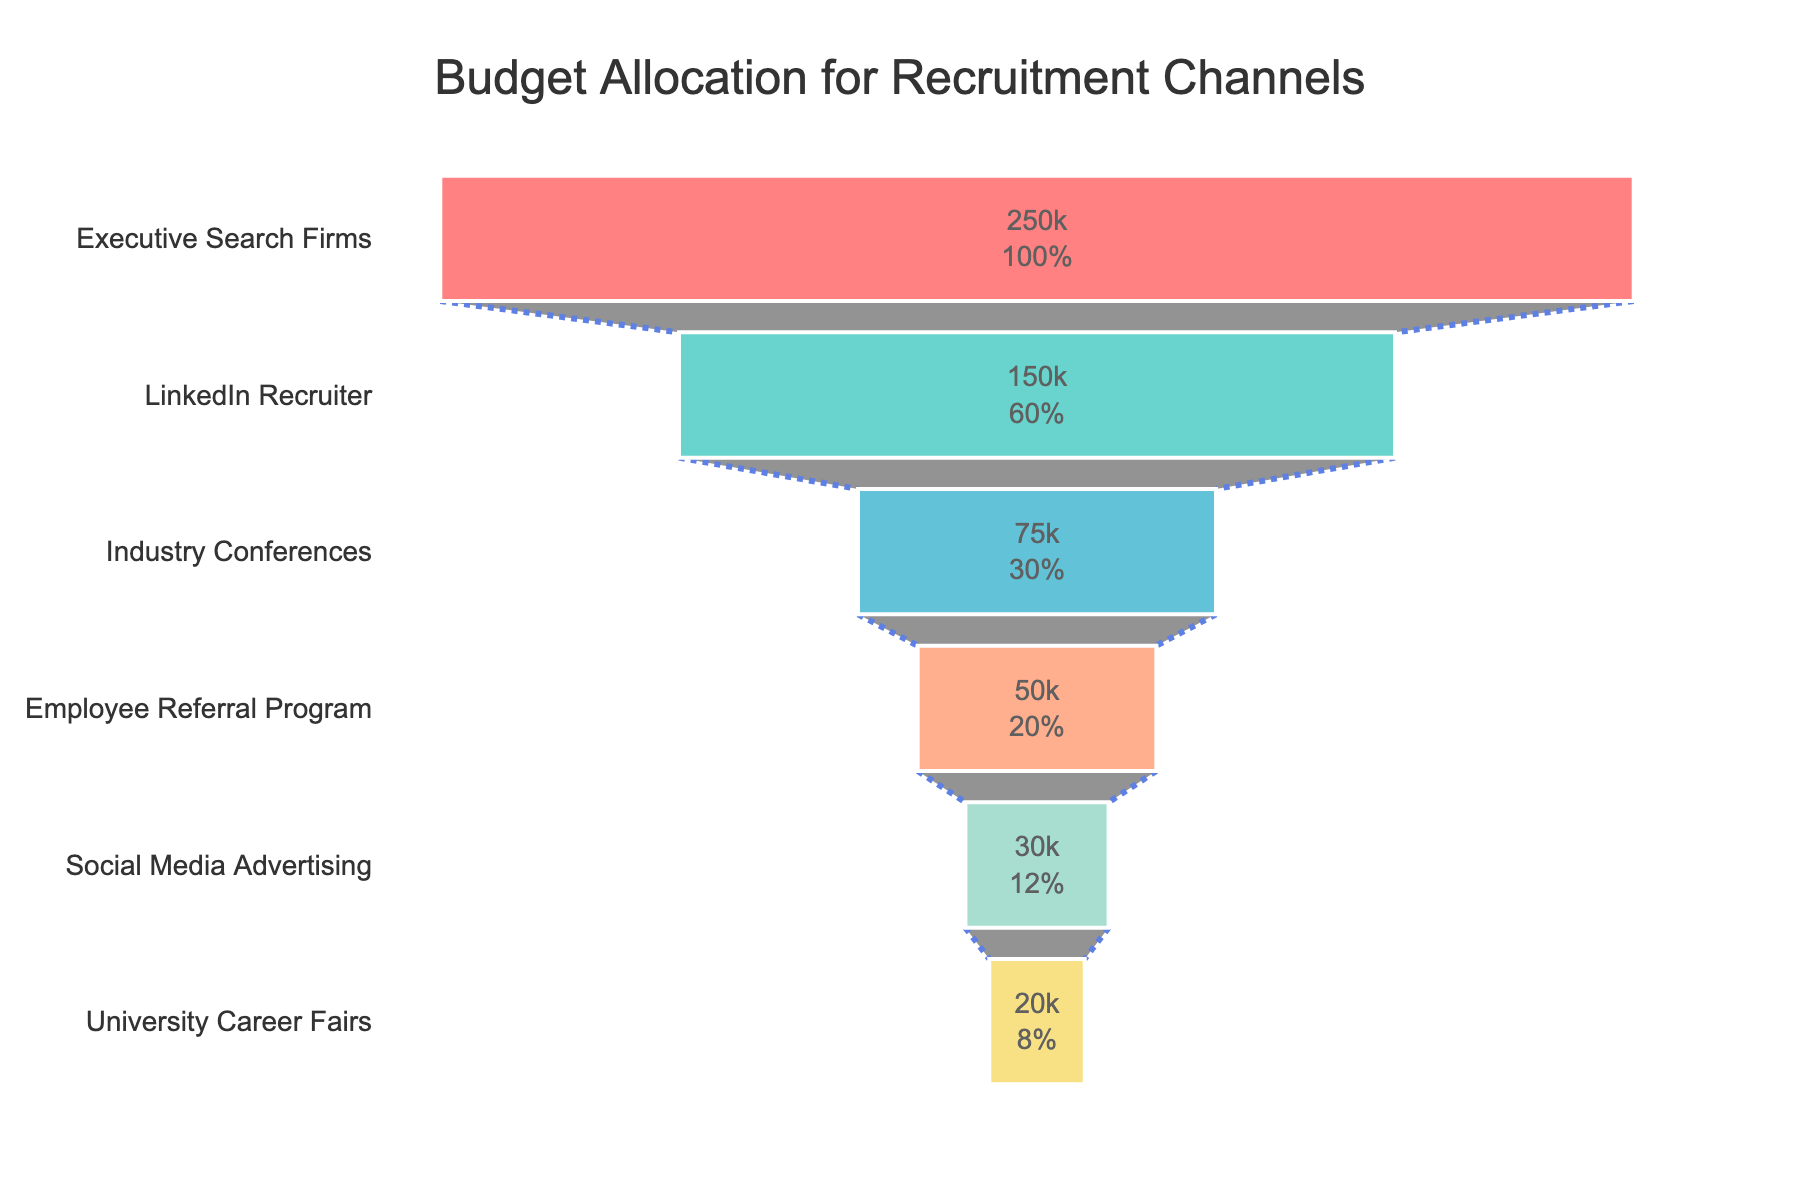What's the title of the funnel chart? The title is located at the top of the chart, usually in a larger and bolder font. In this case, it reads "Budget Allocation for Recruitment Channels".
Answer: Budget Allocation for Recruitment Channels How many recruitment channels are shown in the funnel chart? By counting the distinct sections (which are labeled) depicted along the y-axis, we can see there are 6 recruitment channels.
Answer: 6 Which recruitment channel has the highest budget allocation? The top section of the funnel chart, which is the widest part, represents the recruitment channel with the highest budget allocation. Here, it is labeled as "Executive Search Firms".
Answer: Executive Search Firms How does the budget allocation for LinkedIn Recruiter compare to Industry Conferences? By comparing the widths of the sections labeled "LinkedIn Recruiter" and "Industry Conferences", the corresponding budget allocation values are 150,000 and 75,000 respectively. LinkedIn Recruiter has a higher budget allocation than Industry Conferences.
Answer: LinkedIn Recruiter has a higher budget allocation than Industry Conferences What's the combined budget allocation for Social Media Advertising and University Career Fairs? To find the combined budget allocation, add the values corresponding to both channels. Social Media Advertising has 30,000, and University Career Fairs has 20,000. Summing them up, 30,000 + 20,000 = 50,000.
Answer: 50,000 What percentage of the total budget is allocated to Employee Referral Program? From the chart, the Employee Referral Program has a budget of 50,000. Sum the total budget allocations (250,000 + 150,000 + 75,000 + 50,000 + 30,000 + 20,000 = 575,000). The percentage is (50,000 / 575,000) * 100 = 8.70%.
Answer: 8.70% Which recruitment channel has the smallest budget allocation? The smallest budget allocation is shown at the narrowest (bottom) section of the funnel chart, labeled as "University Career Fairs", which has a budget of 20,000.
Answer: University Career Fairs How much more budget is allocated to Executive Search Firms compared to Employee Referral Program and Social Media Advertising combined? Executive Search Firms have a budget of 250,000. Employee Referral Program and Social Media Advertising combined is 50,000 + 30,000 = 80,000. So, 250,000 - 80,000 = 170,000 more.
Answer: 170,000 more What is the average budget allocation across all recruitment channels? Sum all budget allocations (250,000 + 150,000 + 75,000 + 50,000 + 30,000 + 20,000 = 575,000) and divide by the number of channels (6). The average is 575,000 / 6 ≈ 95,833.33.
Answer: 95,833.33 